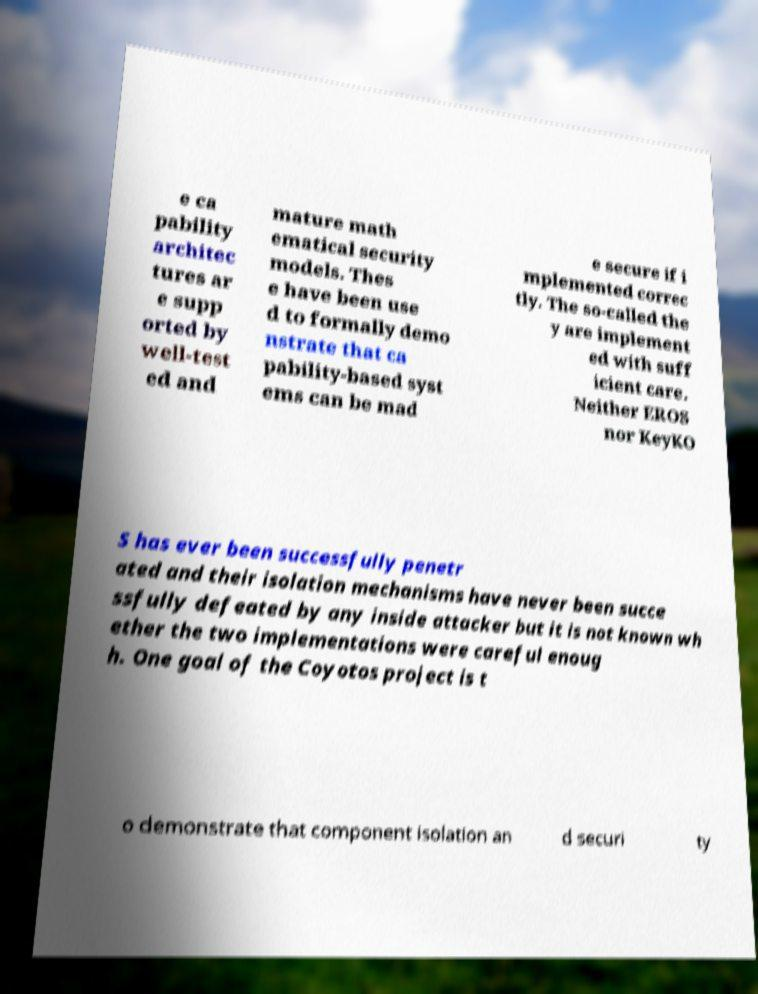Could you extract and type out the text from this image? e ca pability architec tures ar e supp orted by well-test ed and mature math ematical security models. Thes e have been use d to formally demo nstrate that ca pability-based syst ems can be mad e secure if i mplemented correc tly. The so-called the y are implement ed with suff icient care. Neither EROS nor KeyKO S has ever been successfully penetr ated and their isolation mechanisms have never been succe ssfully defeated by any inside attacker but it is not known wh ether the two implementations were careful enoug h. One goal of the Coyotos project is t o demonstrate that component isolation an d securi ty 